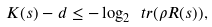Convert formula to latex. <formula><loc_0><loc_0><loc_500><loc_500>K ( s ) - d \leq - \log _ { 2 } \ t r ( \rho R ( s ) ) ,</formula> 